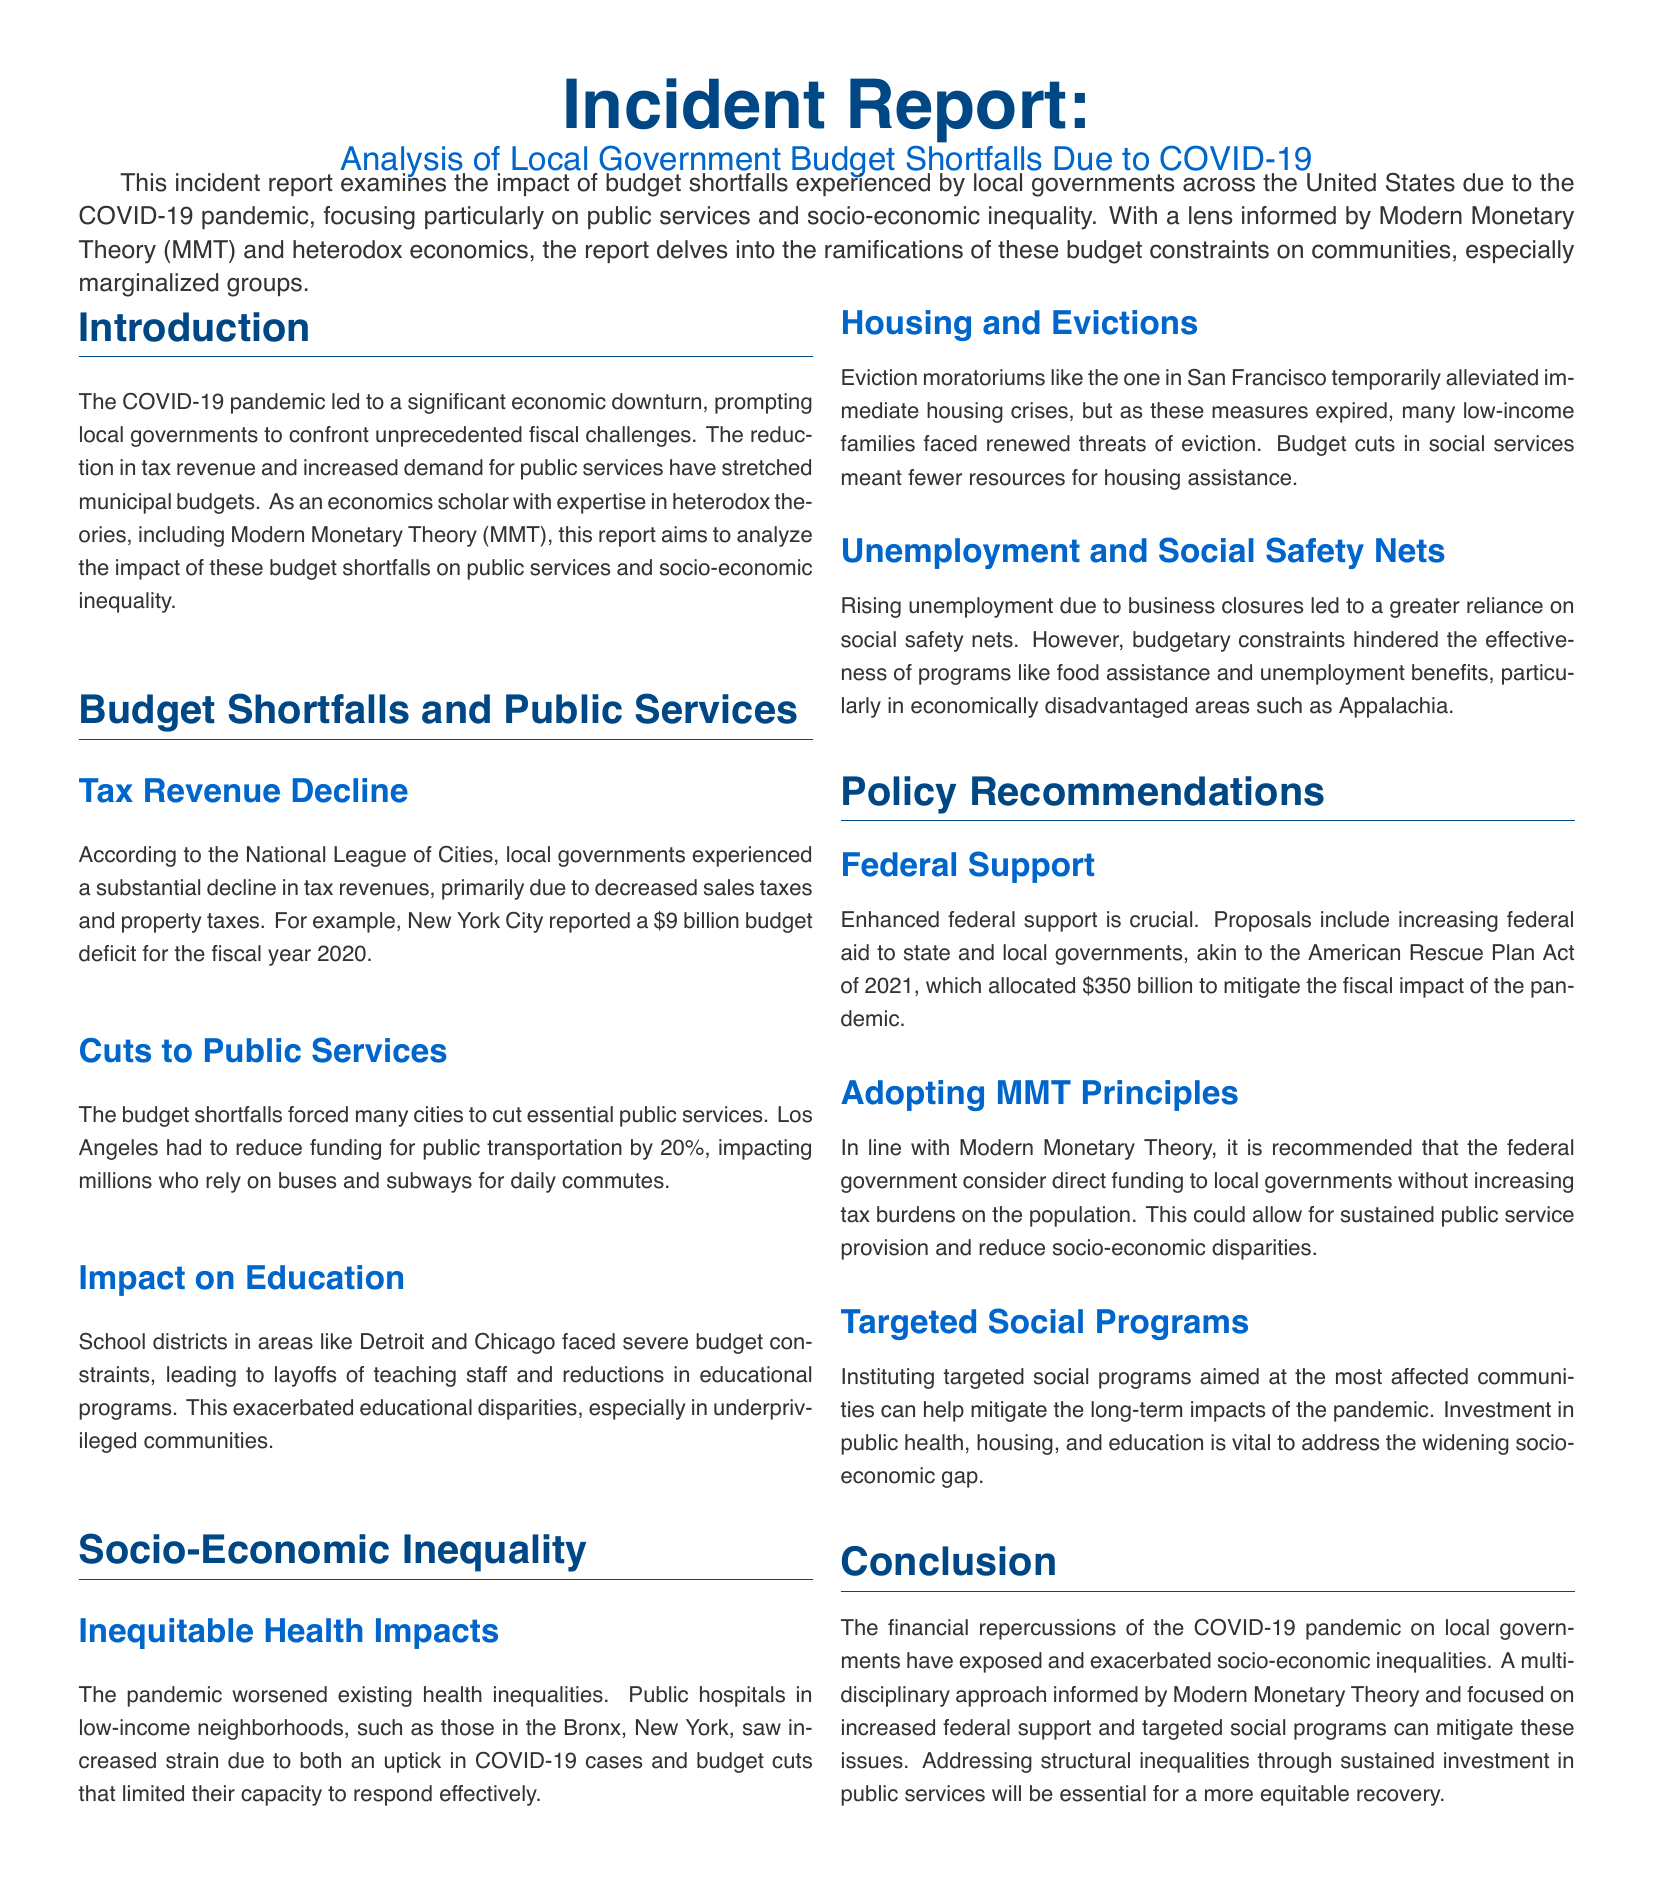what is the title of the incident report? The title of the incident report is provided at the beginning of the document, stating the focus on budget shortfalls.
Answer: Analysis of Local Government Budget Shortfalls Due to COVID-19 what was New York City's reported budget deficit for the fiscal year 2020? The document provides specific information regarding New York City's budget deficit during the pandemic.
Answer: $9 billion what percentage was public transportation funding reduced by in Los Angeles? The report notes the specific cut to public transportation funding due to budget shortfalls.
Answer: 20% which communities faced renewed threats of eviction as moratoriums expired? The document identifies low-income families as those most affected by eviction threats.
Answer: low-income families what federal plan allocated $350 billion to mitigate fiscal impact? The document references a specific federal plan aimed at assisting local governments during the pandemic.
Answer: American Rescue Plan Act of 2021 what economic theory is suggested for direct funding to local governments? The incident report discusses a particular economic theory that supports federal funding approaches.
Answer: Modern Monetary Theory how do budget cuts affect public hospitals in low-income neighborhoods? The document explains the specific impact of budget cuts on public hospitals during the pandemic.
Answer: Increased strain what are the targeted areas for social program investment? The report suggests areas for investment to mitigate long-term impacts on affected communities.
Answer: public health, housing, and education what is the main conclusion regarding the financial repercussions of COVID-19? The conclusion summarizes the broader implications of the pandemic on local governmental finance and inequality.
Answer: Exposed and exacerbated socio-economic inequalities 